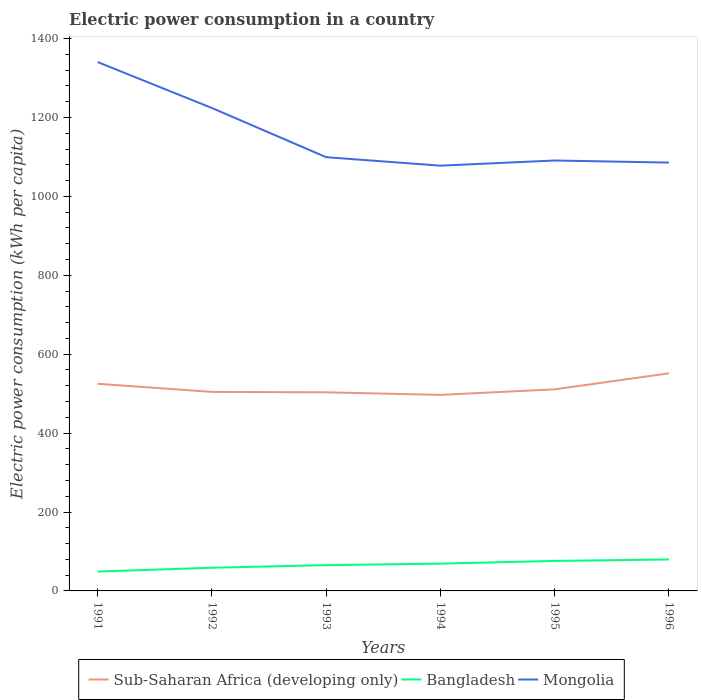How many different coloured lines are there?
Offer a very short reply. 3. Is the number of lines equal to the number of legend labels?
Offer a terse response. Yes. Across all years, what is the maximum electric power consumption in in Bangladesh?
Your answer should be very brief. 49.06. What is the total electric power consumption in in Bangladesh in the graph?
Make the answer very short. -3.6. What is the difference between the highest and the second highest electric power consumption in in Bangladesh?
Keep it short and to the point. 30.61. What is the difference between the highest and the lowest electric power consumption in in Mongolia?
Ensure brevity in your answer.  2. What is the difference between two consecutive major ticks on the Y-axis?
Provide a succinct answer. 200. Are the values on the major ticks of Y-axis written in scientific E-notation?
Provide a succinct answer. No. Does the graph contain any zero values?
Your answer should be compact. No. Where does the legend appear in the graph?
Your answer should be compact. Bottom center. How many legend labels are there?
Your answer should be very brief. 3. What is the title of the graph?
Ensure brevity in your answer.  Electric power consumption in a country. Does "Swaziland" appear as one of the legend labels in the graph?
Ensure brevity in your answer.  No. What is the label or title of the X-axis?
Offer a very short reply. Years. What is the label or title of the Y-axis?
Your answer should be very brief. Electric power consumption (kWh per capita). What is the Electric power consumption (kWh per capita) of Sub-Saharan Africa (developing only) in 1991?
Ensure brevity in your answer.  525.05. What is the Electric power consumption (kWh per capita) of Bangladesh in 1991?
Keep it short and to the point. 49.06. What is the Electric power consumption (kWh per capita) in Mongolia in 1991?
Provide a short and direct response. 1340.45. What is the Electric power consumption (kWh per capita) in Sub-Saharan Africa (developing only) in 1992?
Your response must be concise. 504.42. What is the Electric power consumption (kWh per capita) of Bangladesh in 1992?
Provide a short and direct response. 58.77. What is the Electric power consumption (kWh per capita) of Mongolia in 1992?
Your response must be concise. 1223.98. What is the Electric power consumption (kWh per capita) in Sub-Saharan Africa (developing only) in 1993?
Provide a succinct answer. 503.39. What is the Electric power consumption (kWh per capita) in Bangladesh in 1993?
Make the answer very short. 65.35. What is the Electric power consumption (kWh per capita) of Mongolia in 1993?
Your answer should be compact. 1099.33. What is the Electric power consumption (kWh per capita) of Sub-Saharan Africa (developing only) in 1994?
Your answer should be very brief. 496.9. What is the Electric power consumption (kWh per capita) in Bangladesh in 1994?
Offer a terse response. 69.13. What is the Electric power consumption (kWh per capita) of Mongolia in 1994?
Ensure brevity in your answer.  1077.84. What is the Electric power consumption (kWh per capita) of Sub-Saharan Africa (developing only) in 1995?
Give a very brief answer. 510.9. What is the Electric power consumption (kWh per capita) of Bangladesh in 1995?
Your answer should be compact. 76.08. What is the Electric power consumption (kWh per capita) of Mongolia in 1995?
Give a very brief answer. 1090.93. What is the Electric power consumption (kWh per capita) of Sub-Saharan Africa (developing only) in 1996?
Make the answer very short. 551.54. What is the Electric power consumption (kWh per capita) of Bangladesh in 1996?
Provide a short and direct response. 79.68. What is the Electric power consumption (kWh per capita) of Mongolia in 1996?
Offer a very short reply. 1085.66. Across all years, what is the maximum Electric power consumption (kWh per capita) of Sub-Saharan Africa (developing only)?
Make the answer very short. 551.54. Across all years, what is the maximum Electric power consumption (kWh per capita) in Bangladesh?
Your response must be concise. 79.68. Across all years, what is the maximum Electric power consumption (kWh per capita) of Mongolia?
Give a very brief answer. 1340.45. Across all years, what is the minimum Electric power consumption (kWh per capita) of Sub-Saharan Africa (developing only)?
Offer a terse response. 496.9. Across all years, what is the minimum Electric power consumption (kWh per capita) in Bangladesh?
Your answer should be compact. 49.06. Across all years, what is the minimum Electric power consumption (kWh per capita) of Mongolia?
Offer a terse response. 1077.84. What is the total Electric power consumption (kWh per capita) in Sub-Saharan Africa (developing only) in the graph?
Provide a short and direct response. 3092.19. What is the total Electric power consumption (kWh per capita) of Bangladesh in the graph?
Give a very brief answer. 398.08. What is the total Electric power consumption (kWh per capita) of Mongolia in the graph?
Your answer should be very brief. 6918.17. What is the difference between the Electric power consumption (kWh per capita) in Sub-Saharan Africa (developing only) in 1991 and that in 1992?
Your answer should be compact. 20.63. What is the difference between the Electric power consumption (kWh per capita) of Bangladesh in 1991 and that in 1992?
Your answer should be very brief. -9.71. What is the difference between the Electric power consumption (kWh per capita) in Mongolia in 1991 and that in 1992?
Provide a succinct answer. 116.47. What is the difference between the Electric power consumption (kWh per capita) in Sub-Saharan Africa (developing only) in 1991 and that in 1993?
Provide a short and direct response. 21.66. What is the difference between the Electric power consumption (kWh per capita) in Bangladesh in 1991 and that in 1993?
Provide a succinct answer. -16.29. What is the difference between the Electric power consumption (kWh per capita) in Mongolia in 1991 and that in 1993?
Offer a very short reply. 241.12. What is the difference between the Electric power consumption (kWh per capita) of Sub-Saharan Africa (developing only) in 1991 and that in 1994?
Your response must be concise. 28.15. What is the difference between the Electric power consumption (kWh per capita) of Bangladesh in 1991 and that in 1994?
Provide a short and direct response. -20.06. What is the difference between the Electric power consumption (kWh per capita) of Mongolia in 1991 and that in 1994?
Ensure brevity in your answer.  262.61. What is the difference between the Electric power consumption (kWh per capita) of Sub-Saharan Africa (developing only) in 1991 and that in 1995?
Your answer should be compact. 14.15. What is the difference between the Electric power consumption (kWh per capita) of Bangladesh in 1991 and that in 1995?
Give a very brief answer. -27.02. What is the difference between the Electric power consumption (kWh per capita) in Mongolia in 1991 and that in 1995?
Provide a short and direct response. 249.51. What is the difference between the Electric power consumption (kWh per capita) in Sub-Saharan Africa (developing only) in 1991 and that in 1996?
Your answer should be very brief. -26.49. What is the difference between the Electric power consumption (kWh per capita) in Bangladesh in 1991 and that in 1996?
Offer a terse response. -30.61. What is the difference between the Electric power consumption (kWh per capita) in Mongolia in 1991 and that in 1996?
Keep it short and to the point. 254.79. What is the difference between the Electric power consumption (kWh per capita) in Sub-Saharan Africa (developing only) in 1992 and that in 1993?
Make the answer very short. 1.03. What is the difference between the Electric power consumption (kWh per capita) in Bangladesh in 1992 and that in 1993?
Ensure brevity in your answer.  -6.58. What is the difference between the Electric power consumption (kWh per capita) in Mongolia in 1992 and that in 1993?
Provide a succinct answer. 124.65. What is the difference between the Electric power consumption (kWh per capita) of Sub-Saharan Africa (developing only) in 1992 and that in 1994?
Ensure brevity in your answer.  7.52. What is the difference between the Electric power consumption (kWh per capita) of Bangladesh in 1992 and that in 1994?
Provide a short and direct response. -10.36. What is the difference between the Electric power consumption (kWh per capita) in Mongolia in 1992 and that in 1994?
Provide a succinct answer. 146.14. What is the difference between the Electric power consumption (kWh per capita) of Sub-Saharan Africa (developing only) in 1992 and that in 1995?
Offer a very short reply. -6.48. What is the difference between the Electric power consumption (kWh per capita) of Bangladesh in 1992 and that in 1995?
Provide a succinct answer. -17.31. What is the difference between the Electric power consumption (kWh per capita) of Mongolia in 1992 and that in 1995?
Offer a very short reply. 133.05. What is the difference between the Electric power consumption (kWh per capita) in Sub-Saharan Africa (developing only) in 1992 and that in 1996?
Your answer should be compact. -47.13. What is the difference between the Electric power consumption (kWh per capita) in Bangladesh in 1992 and that in 1996?
Make the answer very short. -20.91. What is the difference between the Electric power consumption (kWh per capita) in Mongolia in 1992 and that in 1996?
Offer a very short reply. 138.32. What is the difference between the Electric power consumption (kWh per capita) of Sub-Saharan Africa (developing only) in 1993 and that in 1994?
Offer a terse response. 6.49. What is the difference between the Electric power consumption (kWh per capita) in Bangladesh in 1993 and that in 1994?
Your answer should be compact. -3.77. What is the difference between the Electric power consumption (kWh per capita) of Mongolia in 1993 and that in 1994?
Provide a succinct answer. 21.49. What is the difference between the Electric power consumption (kWh per capita) of Sub-Saharan Africa (developing only) in 1993 and that in 1995?
Your answer should be very brief. -7.51. What is the difference between the Electric power consumption (kWh per capita) in Bangladesh in 1993 and that in 1995?
Provide a short and direct response. -10.73. What is the difference between the Electric power consumption (kWh per capita) in Mongolia in 1993 and that in 1995?
Your answer should be compact. 8.4. What is the difference between the Electric power consumption (kWh per capita) in Sub-Saharan Africa (developing only) in 1993 and that in 1996?
Provide a succinct answer. -48.15. What is the difference between the Electric power consumption (kWh per capita) of Bangladesh in 1993 and that in 1996?
Your answer should be very brief. -14.32. What is the difference between the Electric power consumption (kWh per capita) in Mongolia in 1993 and that in 1996?
Offer a terse response. 13.67. What is the difference between the Electric power consumption (kWh per capita) of Sub-Saharan Africa (developing only) in 1994 and that in 1995?
Give a very brief answer. -14. What is the difference between the Electric power consumption (kWh per capita) of Bangladesh in 1994 and that in 1995?
Provide a short and direct response. -6.95. What is the difference between the Electric power consumption (kWh per capita) of Mongolia in 1994 and that in 1995?
Ensure brevity in your answer.  -13.09. What is the difference between the Electric power consumption (kWh per capita) in Sub-Saharan Africa (developing only) in 1994 and that in 1996?
Ensure brevity in your answer.  -54.65. What is the difference between the Electric power consumption (kWh per capita) in Bangladesh in 1994 and that in 1996?
Give a very brief answer. -10.55. What is the difference between the Electric power consumption (kWh per capita) of Mongolia in 1994 and that in 1996?
Your answer should be very brief. -7.82. What is the difference between the Electric power consumption (kWh per capita) in Sub-Saharan Africa (developing only) in 1995 and that in 1996?
Your answer should be very brief. -40.64. What is the difference between the Electric power consumption (kWh per capita) of Bangladesh in 1995 and that in 1996?
Your answer should be very brief. -3.6. What is the difference between the Electric power consumption (kWh per capita) of Mongolia in 1995 and that in 1996?
Make the answer very short. 5.27. What is the difference between the Electric power consumption (kWh per capita) in Sub-Saharan Africa (developing only) in 1991 and the Electric power consumption (kWh per capita) in Bangladesh in 1992?
Give a very brief answer. 466.28. What is the difference between the Electric power consumption (kWh per capita) in Sub-Saharan Africa (developing only) in 1991 and the Electric power consumption (kWh per capita) in Mongolia in 1992?
Provide a short and direct response. -698.93. What is the difference between the Electric power consumption (kWh per capita) in Bangladesh in 1991 and the Electric power consumption (kWh per capita) in Mongolia in 1992?
Provide a succinct answer. -1174.91. What is the difference between the Electric power consumption (kWh per capita) in Sub-Saharan Africa (developing only) in 1991 and the Electric power consumption (kWh per capita) in Bangladesh in 1993?
Make the answer very short. 459.7. What is the difference between the Electric power consumption (kWh per capita) in Sub-Saharan Africa (developing only) in 1991 and the Electric power consumption (kWh per capita) in Mongolia in 1993?
Your answer should be very brief. -574.28. What is the difference between the Electric power consumption (kWh per capita) of Bangladesh in 1991 and the Electric power consumption (kWh per capita) of Mongolia in 1993?
Your answer should be very brief. -1050.26. What is the difference between the Electric power consumption (kWh per capita) in Sub-Saharan Africa (developing only) in 1991 and the Electric power consumption (kWh per capita) in Bangladesh in 1994?
Provide a succinct answer. 455.92. What is the difference between the Electric power consumption (kWh per capita) in Sub-Saharan Africa (developing only) in 1991 and the Electric power consumption (kWh per capita) in Mongolia in 1994?
Your response must be concise. -552.79. What is the difference between the Electric power consumption (kWh per capita) in Bangladesh in 1991 and the Electric power consumption (kWh per capita) in Mongolia in 1994?
Provide a short and direct response. -1028.77. What is the difference between the Electric power consumption (kWh per capita) in Sub-Saharan Africa (developing only) in 1991 and the Electric power consumption (kWh per capita) in Bangladesh in 1995?
Make the answer very short. 448.97. What is the difference between the Electric power consumption (kWh per capita) in Sub-Saharan Africa (developing only) in 1991 and the Electric power consumption (kWh per capita) in Mongolia in 1995?
Provide a short and direct response. -565.88. What is the difference between the Electric power consumption (kWh per capita) of Bangladesh in 1991 and the Electric power consumption (kWh per capita) of Mongolia in 1995?
Make the answer very short. -1041.87. What is the difference between the Electric power consumption (kWh per capita) of Sub-Saharan Africa (developing only) in 1991 and the Electric power consumption (kWh per capita) of Bangladesh in 1996?
Provide a succinct answer. 445.37. What is the difference between the Electric power consumption (kWh per capita) in Sub-Saharan Africa (developing only) in 1991 and the Electric power consumption (kWh per capita) in Mongolia in 1996?
Your answer should be very brief. -560.61. What is the difference between the Electric power consumption (kWh per capita) in Bangladesh in 1991 and the Electric power consumption (kWh per capita) in Mongolia in 1996?
Provide a succinct answer. -1036.59. What is the difference between the Electric power consumption (kWh per capita) in Sub-Saharan Africa (developing only) in 1992 and the Electric power consumption (kWh per capita) in Bangladesh in 1993?
Your answer should be compact. 439.06. What is the difference between the Electric power consumption (kWh per capita) in Sub-Saharan Africa (developing only) in 1992 and the Electric power consumption (kWh per capita) in Mongolia in 1993?
Offer a terse response. -594.91. What is the difference between the Electric power consumption (kWh per capita) in Bangladesh in 1992 and the Electric power consumption (kWh per capita) in Mongolia in 1993?
Ensure brevity in your answer.  -1040.55. What is the difference between the Electric power consumption (kWh per capita) in Sub-Saharan Africa (developing only) in 1992 and the Electric power consumption (kWh per capita) in Bangladesh in 1994?
Ensure brevity in your answer.  435.29. What is the difference between the Electric power consumption (kWh per capita) of Sub-Saharan Africa (developing only) in 1992 and the Electric power consumption (kWh per capita) of Mongolia in 1994?
Offer a very short reply. -573.42. What is the difference between the Electric power consumption (kWh per capita) in Bangladesh in 1992 and the Electric power consumption (kWh per capita) in Mongolia in 1994?
Make the answer very short. -1019.06. What is the difference between the Electric power consumption (kWh per capita) of Sub-Saharan Africa (developing only) in 1992 and the Electric power consumption (kWh per capita) of Bangladesh in 1995?
Make the answer very short. 428.34. What is the difference between the Electric power consumption (kWh per capita) of Sub-Saharan Africa (developing only) in 1992 and the Electric power consumption (kWh per capita) of Mongolia in 1995?
Ensure brevity in your answer.  -586.51. What is the difference between the Electric power consumption (kWh per capita) in Bangladesh in 1992 and the Electric power consumption (kWh per capita) in Mongolia in 1995?
Keep it short and to the point. -1032.16. What is the difference between the Electric power consumption (kWh per capita) of Sub-Saharan Africa (developing only) in 1992 and the Electric power consumption (kWh per capita) of Bangladesh in 1996?
Your answer should be compact. 424.74. What is the difference between the Electric power consumption (kWh per capita) in Sub-Saharan Africa (developing only) in 1992 and the Electric power consumption (kWh per capita) in Mongolia in 1996?
Ensure brevity in your answer.  -581.24. What is the difference between the Electric power consumption (kWh per capita) in Bangladesh in 1992 and the Electric power consumption (kWh per capita) in Mongolia in 1996?
Make the answer very short. -1026.88. What is the difference between the Electric power consumption (kWh per capita) of Sub-Saharan Africa (developing only) in 1993 and the Electric power consumption (kWh per capita) of Bangladesh in 1994?
Your answer should be compact. 434.26. What is the difference between the Electric power consumption (kWh per capita) in Sub-Saharan Africa (developing only) in 1993 and the Electric power consumption (kWh per capita) in Mongolia in 1994?
Your response must be concise. -574.45. What is the difference between the Electric power consumption (kWh per capita) in Bangladesh in 1993 and the Electric power consumption (kWh per capita) in Mongolia in 1994?
Ensure brevity in your answer.  -1012.48. What is the difference between the Electric power consumption (kWh per capita) in Sub-Saharan Africa (developing only) in 1993 and the Electric power consumption (kWh per capita) in Bangladesh in 1995?
Your answer should be very brief. 427.31. What is the difference between the Electric power consumption (kWh per capita) of Sub-Saharan Africa (developing only) in 1993 and the Electric power consumption (kWh per capita) of Mongolia in 1995?
Provide a succinct answer. -587.54. What is the difference between the Electric power consumption (kWh per capita) in Bangladesh in 1993 and the Electric power consumption (kWh per capita) in Mongolia in 1995?
Your response must be concise. -1025.58. What is the difference between the Electric power consumption (kWh per capita) in Sub-Saharan Africa (developing only) in 1993 and the Electric power consumption (kWh per capita) in Bangladesh in 1996?
Keep it short and to the point. 423.71. What is the difference between the Electric power consumption (kWh per capita) in Sub-Saharan Africa (developing only) in 1993 and the Electric power consumption (kWh per capita) in Mongolia in 1996?
Keep it short and to the point. -582.27. What is the difference between the Electric power consumption (kWh per capita) in Bangladesh in 1993 and the Electric power consumption (kWh per capita) in Mongolia in 1996?
Offer a very short reply. -1020.3. What is the difference between the Electric power consumption (kWh per capita) in Sub-Saharan Africa (developing only) in 1994 and the Electric power consumption (kWh per capita) in Bangladesh in 1995?
Provide a short and direct response. 420.82. What is the difference between the Electric power consumption (kWh per capita) in Sub-Saharan Africa (developing only) in 1994 and the Electric power consumption (kWh per capita) in Mongolia in 1995?
Your response must be concise. -594.03. What is the difference between the Electric power consumption (kWh per capita) in Bangladesh in 1994 and the Electric power consumption (kWh per capita) in Mongolia in 1995?
Your answer should be very brief. -1021.8. What is the difference between the Electric power consumption (kWh per capita) in Sub-Saharan Africa (developing only) in 1994 and the Electric power consumption (kWh per capita) in Bangladesh in 1996?
Ensure brevity in your answer.  417.22. What is the difference between the Electric power consumption (kWh per capita) of Sub-Saharan Africa (developing only) in 1994 and the Electric power consumption (kWh per capita) of Mongolia in 1996?
Provide a short and direct response. -588.76. What is the difference between the Electric power consumption (kWh per capita) in Bangladesh in 1994 and the Electric power consumption (kWh per capita) in Mongolia in 1996?
Give a very brief answer. -1016.53. What is the difference between the Electric power consumption (kWh per capita) in Sub-Saharan Africa (developing only) in 1995 and the Electric power consumption (kWh per capita) in Bangladesh in 1996?
Offer a very short reply. 431.22. What is the difference between the Electric power consumption (kWh per capita) of Sub-Saharan Africa (developing only) in 1995 and the Electric power consumption (kWh per capita) of Mongolia in 1996?
Make the answer very short. -574.76. What is the difference between the Electric power consumption (kWh per capita) in Bangladesh in 1995 and the Electric power consumption (kWh per capita) in Mongolia in 1996?
Offer a terse response. -1009.58. What is the average Electric power consumption (kWh per capita) in Sub-Saharan Africa (developing only) per year?
Give a very brief answer. 515.37. What is the average Electric power consumption (kWh per capita) of Bangladesh per year?
Make the answer very short. 66.35. What is the average Electric power consumption (kWh per capita) in Mongolia per year?
Give a very brief answer. 1153.03. In the year 1991, what is the difference between the Electric power consumption (kWh per capita) in Sub-Saharan Africa (developing only) and Electric power consumption (kWh per capita) in Bangladesh?
Your answer should be very brief. 475.99. In the year 1991, what is the difference between the Electric power consumption (kWh per capita) in Sub-Saharan Africa (developing only) and Electric power consumption (kWh per capita) in Mongolia?
Provide a short and direct response. -815.39. In the year 1991, what is the difference between the Electric power consumption (kWh per capita) in Bangladesh and Electric power consumption (kWh per capita) in Mongolia?
Make the answer very short. -1291.38. In the year 1992, what is the difference between the Electric power consumption (kWh per capita) in Sub-Saharan Africa (developing only) and Electric power consumption (kWh per capita) in Bangladesh?
Offer a terse response. 445.64. In the year 1992, what is the difference between the Electric power consumption (kWh per capita) in Sub-Saharan Africa (developing only) and Electric power consumption (kWh per capita) in Mongolia?
Offer a terse response. -719.56. In the year 1992, what is the difference between the Electric power consumption (kWh per capita) of Bangladesh and Electric power consumption (kWh per capita) of Mongolia?
Offer a very short reply. -1165.2. In the year 1993, what is the difference between the Electric power consumption (kWh per capita) of Sub-Saharan Africa (developing only) and Electric power consumption (kWh per capita) of Bangladesh?
Make the answer very short. 438.03. In the year 1993, what is the difference between the Electric power consumption (kWh per capita) in Sub-Saharan Africa (developing only) and Electric power consumption (kWh per capita) in Mongolia?
Offer a terse response. -595.94. In the year 1993, what is the difference between the Electric power consumption (kWh per capita) in Bangladesh and Electric power consumption (kWh per capita) in Mongolia?
Ensure brevity in your answer.  -1033.97. In the year 1994, what is the difference between the Electric power consumption (kWh per capita) in Sub-Saharan Africa (developing only) and Electric power consumption (kWh per capita) in Bangladesh?
Offer a very short reply. 427.77. In the year 1994, what is the difference between the Electric power consumption (kWh per capita) of Sub-Saharan Africa (developing only) and Electric power consumption (kWh per capita) of Mongolia?
Give a very brief answer. -580.94. In the year 1994, what is the difference between the Electric power consumption (kWh per capita) of Bangladesh and Electric power consumption (kWh per capita) of Mongolia?
Your answer should be very brief. -1008.71. In the year 1995, what is the difference between the Electric power consumption (kWh per capita) of Sub-Saharan Africa (developing only) and Electric power consumption (kWh per capita) of Bangladesh?
Your answer should be very brief. 434.82. In the year 1995, what is the difference between the Electric power consumption (kWh per capita) in Sub-Saharan Africa (developing only) and Electric power consumption (kWh per capita) in Mongolia?
Your response must be concise. -580.03. In the year 1995, what is the difference between the Electric power consumption (kWh per capita) of Bangladesh and Electric power consumption (kWh per capita) of Mongolia?
Your response must be concise. -1014.85. In the year 1996, what is the difference between the Electric power consumption (kWh per capita) of Sub-Saharan Africa (developing only) and Electric power consumption (kWh per capita) of Bangladesh?
Provide a short and direct response. 471.86. In the year 1996, what is the difference between the Electric power consumption (kWh per capita) in Sub-Saharan Africa (developing only) and Electric power consumption (kWh per capita) in Mongolia?
Your answer should be very brief. -534.11. In the year 1996, what is the difference between the Electric power consumption (kWh per capita) of Bangladesh and Electric power consumption (kWh per capita) of Mongolia?
Ensure brevity in your answer.  -1005.98. What is the ratio of the Electric power consumption (kWh per capita) in Sub-Saharan Africa (developing only) in 1991 to that in 1992?
Offer a terse response. 1.04. What is the ratio of the Electric power consumption (kWh per capita) of Bangladesh in 1991 to that in 1992?
Your response must be concise. 0.83. What is the ratio of the Electric power consumption (kWh per capita) of Mongolia in 1991 to that in 1992?
Ensure brevity in your answer.  1.1. What is the ratio of the Electric power consumption (kWh per capita) of Sub-Saharan Africa (developing only) in 1991 to that in 1993?
Provide a succinct answer. 1.04. What is the ratio of the Electric power consumption (kWh per capita) in Bangladesh in 1991 to that in 1993?
Provide a short and direct response. 0.75. What is the ratio of the Electric power consumption (kWh per capita) in Mongolia in 1991 to that in 1993?
Provide a succinct answer. 1.22. What is the ratio of the Electric power consumption (kWh per capita) of Sub-Saharan Africa (developing only) in 1991 to that in 1994?
Provide a succinct answer. 1.06. What is the ratio of the Electric power consumption (kWh per capita) of Bangladesh in 1991 to that in 1994?
Offer a very short reply. 0.71. What is the ratio of the Electric power consumption (kWh per capita) of Mongolia in 1991 to that in 1994?
Ensure brevity in your answer.  1.24. What is the ratio of the Electric power consumption (kWh per capita) in Sub-Saharan Africa (developing only) in 1991 to that in 1995?
Offer a very short reply. 1.03. What is the ratio of the Electric power consumption (kWh per capita) of Bangladesh in 1991 to that in 1995?
Your response must be concise. 0.64. What is the ratio of the Electric power consumption (kWh per capita) of Mongolia in 1991 to that in 1995?
Give a very brief answer. 1.23. What is the ratio of the Electric power consumption (kWh per capita) in Bangladesh in 1991 to that in 1996?
Ensure brevity in your answer.  0.62. What is the ratio of the Electric power consumption (kWh per capita) of Mongolia in 1991 to that in 1996?
Keep it short and to the point. 1.23. What is the ratio of the Electric power consumption (kWh per capita) of Bangladesh in 1992 to that in 1993?
Ensure brevity in your answer.  0.9. What is the ratio of the Electric power consumption (kWh per capita) in Mongolia in 1992 to that in 1993?
Make the answer very short. 1.11. What is the ratio of the Electric power consumption (kWh per capita) in Sub-Saharan Africa (developing only) in 1992 to that in 1994?
Provide a short and direct response. 1.02. What is the ratio of the Electric power consumption (kWh per capita) of Bangladesh in 1992 to that in 1994?
Your answer should be compact. 0.85. What is the ratio of the Electric power consumption (kWh per capita) in Mongolia in 1992 to that in 1994?
Ensure brevity in your answer.  1.14. What is the ratio of the Electric power consumption (kWh per capita) of Sub-Saharan Africa (developing only) in 1992 to that in 1995?
Make the answer very short. 0.99. What is the ratio of the Electric power consumption (kWh per capita) of Bangladesh in 1992 to that in 1995?
Offer a terse response. 0.77. What is the ratio of the Electric power consumption (kWh per capita) of Mongolia in 1992 to that in 1995?
Keep it short and to the point. 1.12. What is the ratio of the Electric power consumption (kWh per capita) of Sub-Saharan Africa (developing only) in 1992 to that in 1996?
Your response must be concise. 0.91. What is the ratio of the Electric power consumption (kWh per capita) of Bangladesh in 1992 to that in 1996?
Ensure brevity in your answer.  0.74. What is the ratio of the Electric power consumption (kWh per capita) of Mongolia in 1992 to that in 1996?
Provide a short and direct response. 1.13. What is the ratio of the Electric power consumption (kWh per capita) in Sub-Saharan Africa (developing only) in 1993 to that in 1994?
Give a very brief answer. 1.01. What is the ratio of the Electric power consumption (kWh per capita) in Bangladesh in 1993 to that in 1994?
Make the answer very short. 0.95. What is the ratio of the Electric power consumption (kWh per capita) of Mongolia in 1993 to that in 1994?
Your answer should be very brief. 1.02. What is the ratio of the Electric power consumption (kWh per capita) of Sub-Saharan Africa (developing only) in 1993 to that in 1995?
Provide a succinct answer. 0.99. What is the ratio of the Electric power consumption (kWh per capita) of Bangladesh in 1993 to that in 1995?
Ensure brevity in your answer.  0.86. What is the ratio of the Electric power consumption (kWh per capita) of Mongolia in 1993 to that in 1995?
Your response must be concise. 1.01. What is the ratio of the Electric power consumption (kWh per capita) of Sub-Saharan Africa (developing only) in 1993 to that in 1996?
Ensure brevity in your answer.  0.91. What is the ratio of the Electric power consumption (kWh per capita) in Bangladesh in 1993 to that in 1996?
Offer a terse response. 0.82. What is the ratio of the Electric power consumption (kWh per capita) in Mongolia in 1993 to that in 1996?
Provide a short and direct response. 1.01. What is the ratio of the Electric power consumption (kWh per capita) of Sub-Saharan Africa (developing only) in 1994 to that in 1995?
Provide a short and direct response. 0.97. What is the ratio of the Electric power consumption (kWh per capita) in Bangladesh in 1994 to that in 1995?
Give a very brief answer. 0.91. What is the ratio of the Electric power consumption (kWh per capita) in Sub-Saharan Africa (developing only) in 1994 to that in 1996?
Ensure brevity in your answer.  0.9. What is the ratio of the Electric power consumption (kWh per capita) of Bangladesh in 1994 to that in 1996?
Your response must be concise. 0.87. What is the ratio of the Electric power consumption (kWh per capita) of Sub-Saharan Africa (developing only) in 1995 to that in 1996?
Ensure brevity in your answer.  0.93. What is the ratio of the Electric power consumption (kWh per capita) of Bangladesh in 1995 to that in 1996?
Ensure brevity in your answer.  0.95. What is the difference between the highest and the second highest Electric power consumption (kWh per capita) of Sub-Saharan Africa (developing only)?
Provide a short and direct response. 26.49. What is the difference between the highest and the second highest Electric power consumption (kWh per capita) in Bangladesh?
Your response must be concise. 3.6. What is the difference between the highest and the second highest Electric power consumption (kWh per capita) of Mongolia?
Give a very brief answer. 116.47. What is the difference between the highest and the lowest Electric power consumption (kWh per capita) in Sub-Saharan Africa (developing only)?
Provide a succinct answer. 54.65. What is the difference between the highest and the lowest Electric power consumption (kWh per capita) in Bangladesh?
Provide a succinct answer. 30.61. What is the difference between the highest and the lowest Electric power consumption (kWh per capita) of Mongolia?
Provide a succinct answer. 262.61. 